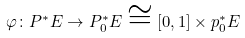<formula> <loc_0><loc_0><loc_500><loc_500>\varphi \colon P ^ { * } E \to P _ { 0 } ^ { * } E \cong [ 0 , 1 ] \times p _ { 0 } ^ { * } E</formula> 